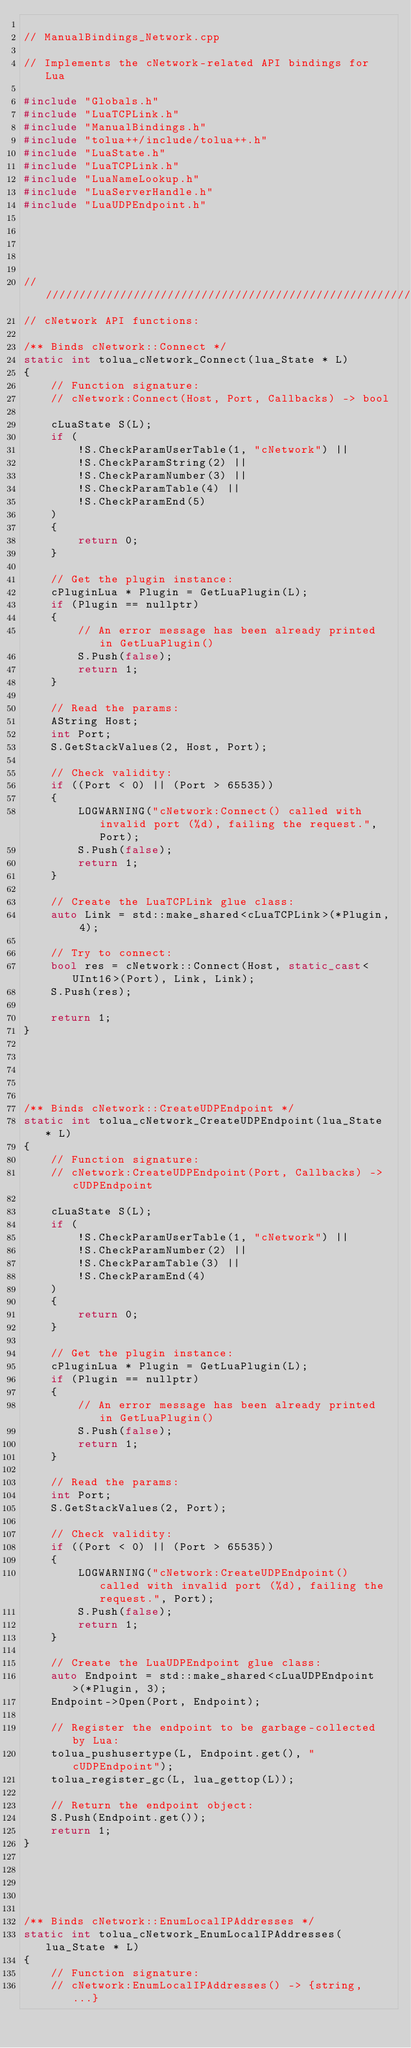<code> <loc_0><loc_0><loc_500><loc_500><_C++_>
// ManualBindings_Network.cpp

// Implements the cNetwork-related API bindings for Lua

#include "Globals.h"
#include "LuaTCPLink.h"
#include "ManualBindings.h"
#include "tolua++/include/tolua++.h"
#include "LuaState.h"
#include "LuaTCPLink.h"
#include "LuaNameLookup.h"
#include "LuaServerHandle.h"
#include "LuaUDPEndpoint.h"





////////////////////////////////////////////////////////////////////////////////
// cNetwork API functions:

/** Binds cNetwork::Connect */
static int tolua_cNetwork_Connect(lua_State * L)
{
	// Function signature:
	// cNetwork:Connect(Host, Port, Callbacks) -> bool

	cLuaState S(L);
	if (
		!S.CheckParamUserTable(1, "cNetwork") ||
		!S.CheckParamString(2) ||
		!S.CheckParamNumber(3) ||
		!S.CheckParamTable(4) ||
		!S.CheckParamEnd(5)
	)
	{
		return 0;
	}
	
	// Get the plugin instance:
	cPluginLua * Plugin = GetLuaPlugin(L);
	if (Plugin == nullptr)
	{
		// An error message has been already printed in GetLuaPlugin()
		S.Push(false);
		return 1;
	}

	// Read the params:
	AString Host;
	int Port;
	S.GetStackValues(2, Host, Port);

	// Check validity:
	if ((Port < 0) || (Port > 65535))
	{
		LOGWARNING("cNetwork:Connect() called with invalid port (%d), failing the request.", Port);
		S.Push(false);
		return 1;
	}

	// Create the LuaTCPLink glue class:
	auto Link = std::make_shared<cLuaTCPLink>(*Plugin, 4);

	// Try to connect:
	bool res = cNetwork::Connect(Host, static_cast<UInt16>(Port), Link, Link);
	S.Push(res);

	return 1;
}





/** Binds cNetwork::CreateUDPEndpoint */
static int tolua_cNetwork_CreateUDPEndpoint(lua_State * L)
{
	// Function signature:
	// cNetwork:CreateUDPEndpoint(Port, Callbacks) -> cUDPEndpoint

	cLuaState S(L);
	if (
		!S.CheckParamUserTable(1, "cNetwork") ||
		!S.CheckParamNumber(2) ||
		!S.CheckParamTable(3) ||
		!S.CheckParamEnd(4)
	)
	{
		return 0;
	}
	
	// Get the plugin instance:
	cPluginLua * Plugin = GetLuaPlugin(L);
	if (Plugin == nullptr)
	{
		// An error message has been already printed in GetLuaPlugin()
		S.Push(false);
		return 1;
	}

	// Read the params:
	int Port;
	S.GetStackValues(2, Port);

	// Check validity:
	if ((Port < 0) || (Port > 65535))
	{
		LOGWARNING("cNetwork:CreateUDPEndpoint() called with invalid port (%d), failing the request.", Port);
		S.Push(false);
		return 1;
	}

	// Create the LuaUDPEndpoint glue class:
	auto Endpoint = std::make_shared<cLuaUDPEndpoint>(*Plugin, 3);
	Endpoint->Open(Port, Endpoint);

	// Register the endpoint to be garbage-collected by Lua:
	tolua_pushusertype(L, Endpoint.get(), "cUDPEndpoint");
	tolua_register_gc(L, lua_gettop(L));

	// Return the endpoint object:
	S.Push(Endpoint.get());
	return 1;
}





/** Binds cNetwork::EnumLocalIPAddresses */
static int tolua_cNetwork_EnumLocalIPAddresses(lua_State * L)
{
	// Function signature:
	// cNetwork:EnumLocalIPAddresses() -> {string, ...}
</code> 